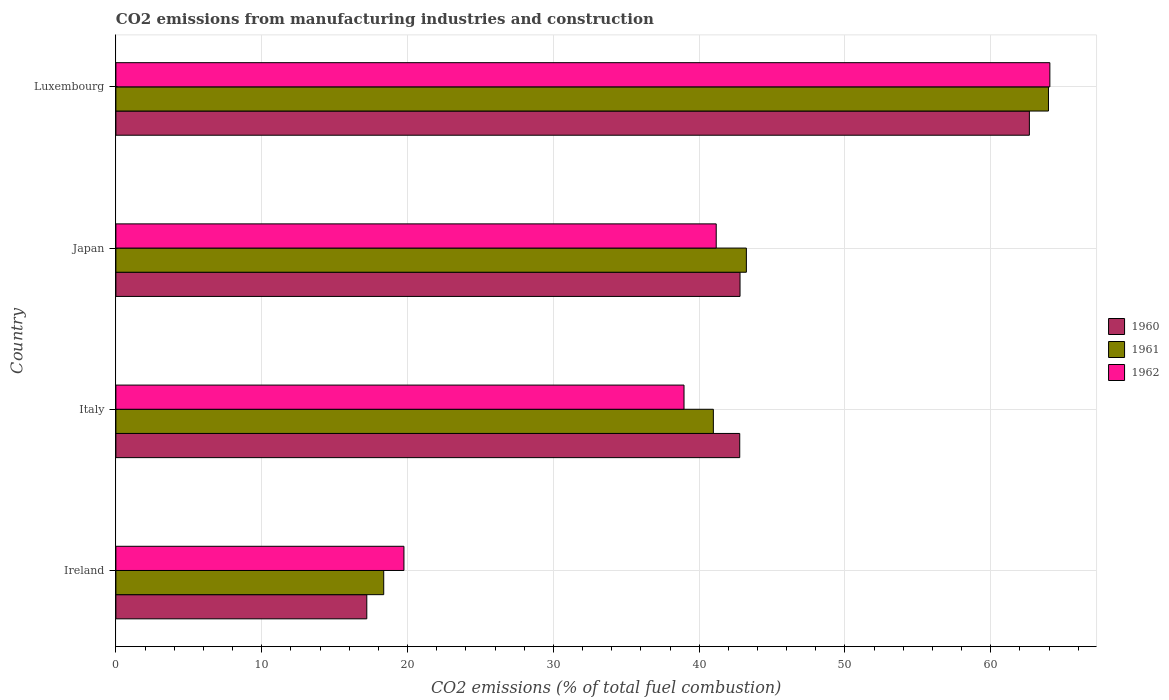How many different coloured bars are there?
Make the answer very short. 3. Are the number of bars on each tick of the Y-axis equal?
Offer a very short reply. Yes. How many bars are there on the 1st tick from the top?
Keep it short and to the point. 3. How many bars are there on the 3rd tick from the bottom?
Your answer should be compact. 3. What is the label of the 4th group of bars from the top?
Offer a terse response. Ireland. In how many cases, is the number of bars for a given country not equal to the number of legend labels?
Offer a terse response. 0. What is the amount of CO2 emitted in 1961 in Luxembourg?
Your answer should be very brief. 63.95. Across all countries, what is the maximum amount of CO2 emitted in 1962?
Give a very brief answer. 64.05. Across all countries, what is the minimum amount of CO2 emitted in 1960?
Ensure brevity in your answer.  17.21. In which country was the amount of CO2 emitted in 1962 maximum?
Offer a terse response. Luxembourg. In which country was the amount of CO2 emitted in 1961 minimum?
Provide a succinct answer. Ireland. What is the total amount of CO2 emitted in 1962 in the graph?
Provide a short and direct response. 163.93. What is the difference between the amount of CO2 emitted in 1961 in Italy and that in Japan?
Your answer should be very brief. -2.26. What is the difference between the amount of CO2 emitted in 1961 in Luxembourg and the amount of CO2 emitted in 1960 in Ireland?
Offer a terse response. 46.75. What is the average amount of CO2 emitted in 1961 per country?
Your response must be concise. 41.63. What is the difference between the amount of CO2 emitted in 1961 and amount of CO2 emitted in 1960 in Ireland?
Make the answer very short. 1.16. In how many countries, is the amount of CO2 emitted in 1962 greater than 18 %?
Your answer should be very brief. 4. What is the ratio of the amount of CO2 emitted in 1962 in Italy to that in Luxembourg?
Ensure brevity in your answer.  0.61. Is the amount of CO2 emitted in 1961 in Ireland less than that in Italy?
Provide a short and direct response. Yes. Is the difference between the amount of CO2 emitted in 1961 in Ireland and Italy greater than the difference between the amount of CO2 emitted in 1960 in Ireland and Italy?
Make the answer very short. Yes. What is the difference between the highest and the second highest amount of CO2 emitted in 1962?
Keep it short and to the point. 22.88. What is the difference between the highest and the lowest amount of CO2 emitted in 1960?
Provide a short and direct response. 45.44. Is the sum of the amount of CO2 emitted in 1962 in Ireland and Japan greater than the maximum amount of CO2 emitted in 1961 across all countries?
Your answer should be compact. No. What does the 2nd bar from the top in Luxembourg represents?
Give a very brief answer. 1961. How many bars are there?
Make the answer very short. 12. Does the graph contain any zero values?
Provide a succinct answer. No. Does the graph contain grids?
Make the answer very short. Yes. Where does the legend appear in the graph?
Provide a short and direct response. Center right. How are the legend labels stacked?
Keep it short and to the point. Vertical. What is the title of the graph?
Your answer should be very brief. CO2 emissions from manufacturing industries and construction. What is the label or title of the X-axis?
Give a very brief answer. CO2 emissions (% of total fuel combustion). What is the CO2 emissions (% of total fuel combustion) in 1960 in Ireland?
Ensure brevity in your answer.  17.21. What is the CO2 emissions (% of total fuel combustion) of 1961 in Ireland?
Your answer should be compact. 18.37. What is the CO2 emissions (% of total fuel combustion) in 1962 in Ireland?
Your answer should be compact. 19.75. What is the CO2 emissions (% of total fuel combustion) of 1960 in Italy?
Keep it short and to the point. 42.78. What is the CO2 emissions (% of total fuel combustion) of 1961 in Italy?
Offer a very short reply. 40.97. What is the CO2 emissions (% of total fuel combustion) in 1962 in Italy?
Ensure brevity in your answer.  38.96. What is the CO2 emissions (% of total fuel combustion) of 1960 in Japan?
Your answer should be very brief. 42.8. What is the CO2 emissions (% of total fuel combustion) of 1961 in Japan?
Your answer should be very brief. 43.24. What is the CO2 emissions (% of total fuel combustion) in 1962 in Japan?
Offer a very short reply. 41.17. What is the CO2 emissions (% of total fuel combustion) in 1960 in Luxembourg?
Your answer should be very brief. 62.65. What is the CO2 emissions (% of total fuel combustion) in 1961 in Luxembourg?
Provide a succinct answer. 63.95. What is the CO2 emissions (% of total fuel combustion) of 1962 in Luxembourg?
Give a very brief answer. 64.05. Across all countries, what is the maximum CO2 emissions (% of total fuel combustion) of 1960?
Make the answer very short. 62.65. Across all countries, what is the maximum CO2 emissions (% of total fuel combustion) in 1961?
Offer a terse response. 63.95. Across all countries, what is the maximum CO2 emissions (% of total fuel combustion) of 1962?
Ensure brevity in your answer.  64.05. Across all countries, what is the minimum CO2 emissions (% of total fuel combustion) in 1960?
Provide a succinct answer. 17.21. Across all countries, what is the minimum CO2 emissions (% of total fuel combustion) of 1961?
Make the answer very short. 18.37. Across all countries, what is the minimum CO2 emissions (% of total fuel combustion) of 1962?
Provide a short and direct response. 19.75. What is the total CO2 emissions (% of total fuel combustion) in 1960 in the graph?
Give a very brief answer. 165.44. What is the total CO2 emissions (% of total fuel combustion) of 1961 in the graph?
Your answer should be compact. 166.53. What is the total CO2 emissions (% of total fuel combustion) of 1962 in the graph?
Offer a very short reply. 163.93. What is the difference between the CO2 emissions (% of total fuel combustion) in 1960 in Ireland and that in Italy?
Your answer should be very brief. -25.57. What is the difference between the CO2 emissions (% of total fuel combustion) in 1961 in Ireland and that in Italy?
Your answer should be compact. -22.61. What is the difference between the CO2 emissions (% of total fuel combustion) of 1962 in Ireland and that in Italy?
Keep it short and to the point. -19.21. What is the difference between the CO2 emissions (% of total fuel combustion) in 1960 in Ireland and that in Japan?
Your answer should be very brief. -25.6. What is the difference between the CO2 emissions (% of total fuel combustion) of 1961 in Ireland and that in Japan?
Make the answer very short. -24.87. What is the difference between the CO2 emissions (% of total fuel combustion) of 1962 in Ireland and that in Japan?
Offer a terse response. -21.42. What is the difference between the CO2 emissions (% of total fuel combustion) in 1960 in Ireland and that in Luxembourg?
Make the answer very short. -45.44. What is the difference between the CO2 emissions (% of total fuel combustion) of 1961 in Ireland and that in Luxembourg?
Your response must be concise. -45.59. What is the difference between the CO2 emissions (% of total fuel combustion) of 1962 in Ireland and that in Luxembourg?
Your response must be concise. -44.3. What is the difference between the CO2 emissions (% of total fuel combustion) of 1960 in Italy and that in Japan?
Your answer should be very brief. -0.02. What is the difference between the CO2 emissions (% of total fuel combustion) in 1961 in Italy and that in Japan?
Offer a very short reply. -2.26. What is the difference between the CO2 emissions (% of total fuel combustion) in 1962 in Italy and that in Japan?
Your answer should be compact. -2.21. What is the difference between the CO2 emissions (% of total fuel combustion) in 1960 in Italy and that in Luxembourg?
Provide a short and direct response. -19.86. What is the difference between the CO2 emissions (% of total fuel combustion) of 1961 in Italy and that in Luxembourg?
Offer a terse response. -22.98. What is the difference between the CO2 emissions (% of total fuel combustion) of 1962 in Italy and that in Luxembourg?
Make the answer very short. -25.09. What is the difference between the CO2 emissions (% of total fuel combustion) of 1960 in Japan and that in Luxembourg?
Provide a short and direct response. -19.84. What is the difference between the CO2 emissions (% of total fuel combustion) in 1961 in Japan and that in Luxembourg?
Offer a very short reply. -20.72. What is the difference between the CO2 emissions (% of total fuel combustion) in 1962 in Japan and that in Luxembourg?
Your answer should be compact. -22.88. What is the difference between the CO2 emissions (% of total fuel combustion) of 1960 in Ireland and the CO2 emissions (% of total fuel combustion) of 1961 in Italy?
Your response must be concise. -23.77. What is the difference between the CO2 emissions (% of total fuel combustion) in 1960 in Ireland and the CO2 emissions (% of total fuel combustion) in 1962 in Italy?
Your response must be concise. -21.75. What is the difference between the CO2 emissions (% of total fuel combustion) of 1961 in Ireland and the CO2 emissions (% of total fuel combustion) of 1962 in Italy?
Your answer should be compact. -20.59. What is the difference between the CO2 emissions (% of total fuel combustion) in 1960 in Ireland and the CO2 emissions (% of total fuel combustion) in 1961 in Japan?
Provide a succinct answer. -26.03. What is the difference between the CO2 emissions (% of total fuel combustion) in 1960 in Ireland and the CO2 emissions (% of total fuel combustion) in 1962 in Japan?
Provide a short and direct response. -23.96. What is the difference between the CO2 emissions (% of total fuel combustion) of 1961 in Ireland and the CO2 emissions (% of total fuel combustion) of 1962 in Japan?
Your response must be concise. -22.8. What is the difference between the CO2 emissions (% of total fuel combustion) of 1960 in Ireland and the CO2 emissions (% of total fuel combustion) of 1961 in Luxembourg?
Provide a short and direct response. -46.75. What is the difference between the CO2 emissions (% of total fuel combustion) of 1960 in Ireland and the CO2 emissions (% of total fuel combustion) of 1962 in Luxembourg?
Offer a very short reply. -46.84. What is the difference between the CO2 emissions (% of total fuel combustion) of 1961 in Ireland and the CO2 emissions (% of total fuel combustion) of 1962 in Luxembourg?
Ensure brevity in your answer.  -45.68. What is the difference between the CO2 emissions (% of total fuel combustion) of 1960 in Italy and the CO2 emissions (% of total fuel combustion) of 1961 in Japan?
Ensure brevity in your answer.  -0.46. What is the difference between the CO2 emissions (% of total fuel combustion) of 1960 in Italy and the CO2 emissions (% of total fuel combustion) of 1962 in Japan?
Offer a very short reply. 1.61. What is the difference between the CO2 emissions (% of total fuel combustion) of 1961 in Italy and the CO2 emissions (% of total fuel combustion) of 1962 in Japan?
Offer a very short reply. -0.2. What is the difference between the CO2 emissions (% of total fuel combustion) in 1960 in Italy and the CO2 emissions (% of total fuel combustion) in 1961 in Luxembourg?
Keep it short and to the point. -21.17. What is the difference between the CO2 emissions (% of total fuel combustion) in 1960 in Italy and the CO2 emissions (% of total fuel combustion) in 1962 in Luxembourg?
Your answer should be very brief. -21.27. What is the difference between the CO2 emissions (% of total fuel combustion) in 1961 in Italy and the CO2 emissions (% of total fuel combustion) in 1962 in Luxembourg?
Your answer should be very brief. -23.08. What is the difference between the CO2 emissions (% of total fuel combustion) in 1960 in Japan and the CO2 emissions (% of total fuel combustion) in 1961 in Luxembourg?
Ensure brevity in your answer.  -21.15. What is the difference between the CO2 emissions (% of total fuel combustion) of 1960 in Japan and the CO2 emissions (% of total fuel combustion) of 1962 in Luxembourg?
Keep it short and to the point. -21.25. What is the difference between the CO2 emissions (% of total fuel combustion) in 1961 in Japan and the CO2 emissions (% of total fuel combustion) in 1962 in Luxembourg?
Your response must be concise. -20.81. What is the average CO2 emissions (% of total fuel combustion) in 1960 per country?
Keep it short and to the point. 41.36. What is the average CO2 emissions (% of total fuel combustion) of 1961 per country?
Give a very brief answer. 41.63. What is the average CO2 emissions (% of total fuel combustion) in 1962 per country?
Your response must be concise. 40.98. What is the difference between the CO2 emissions (% of total fuel combustion) of 1960 and CO2 emissions (% of total fuel combustion) of 1961 in Ireland?
Give a very brief answer. -1.16. What is the difference between the CO2 emissions (% of total fuel combustion) of 1960 and CO2 emissions (% of total fuel combustion) of 1962 in Ireland?
Offer a very short reply. -2.55. What is the difference between the CO2 emissions (% of total fuel combustion) in 1961 and CO2 emissions (% of total fuel combustion) in 1962 in Ireland?
Your response must be concise. -1.39. What is the difference between the CO2 emissions (% of total fuel combustion) in 1960 and CO2 emissions (% of total fuel combustion) in 1961 in Italy?
Make the answer very short. 1.81. What is the difference between the CO2 emissions (% of total fuel combustion) in 1960 and CO2 emissions (% of total fuel combustion) in 1962 in Italy?
Keep it short and to the point. 3.82. What is the difference between the CO2 emissions (% of total fuel combustion) of 1961 and CO2 emissions (% of total fuel combustion) of 1962 in Italy?
Offer a terse response. 2.01. What is the difference between the CO2 emissions (% of total fuel combustion) in 1960 and CO2 emissions (% of total fuel combustion) in 1961 in Japan?
Offer a very short reply. -0.44. What is the difference between the CO2 emissions (% of total fuel combustion) in 1960 and CO2 emissions (% of total fuel combustion) in 1962 in Japan?
Provide a succinct answer. 1.63. What is the difference between the CO2 emissions (% of total fuel combustion) in 1961 and CO2 emissions (% of total fuel combustion) in 1962 in Japan?
Offer a terse response. 2.07. What is the difference between the CO2 emissions (% of total fuel combustion) in 1960 and CO2 emissions (% of total fuel combustion) in 1961 in Luxembourg?
Offer a terse response. -1.31. What is the difference between the CO2 emissions (% of total fuel combustion) of 1960 and CO2 emissions (% of total fuel combustion) of 1962 in Luxembourg?
Your response must be concise. -1.4. What is the difference between the CO2 emissions (% of total fuel combustion) in 1961 and CO2 emissions (% of total fuel combustion) in 1962 in Luxembourg?
Provide a succinct answer. -0.1. What is the ratio of the CO2 emissions (% of total fuel combustion) in 1960 in Ireland to that in Italy?
Your response must be concise. 0.4. What is the ratio of the CO2 emissions (% of total fuel combustion) of 1961 in Ireland to that in Italy?
Your answer should be very brief. 0.45. What is the ratio of the CO2 emissions (% of total fuel combustion) of 1962 in Ireland to that in Italy?
Your response must be concise. 0.51. What is the ratio of the CO2 emissions (% of total fuel combustion) in 1960 in Ireland to that in Japan?
Provide a succinct answer. 0.4. What is the ratio of the CO2 emissions (% of total fuel combustion) in 1961 in Ireland to that in Japan?
Offer a terse response. 0.42. What is the ratio of the CO2 emissions (% of total fuel combustion) in 1962 in Ireland to that in Japan?
Offer a terse response. 0.48. What is the ratio of the CO2 emissions (% of total fuel combustion) in 1960 in Ireland to that in Luxembourg?
Give a very brief answer. 0.27. What is the ratio of the CO2 emissions (% of total fuel combustion) of 1961 in Ireland to that in Luxembourg?
Make the answer very short. 0.29. What is the ratio of the CO2 emissions (% of total fuel combustion) in 1962 in Ireland to that in Luxembourg?
Offer a terse response. 0.31. What is the ratio of the CO2 emissions (% of total fuel combustion) in 1961 in Italy to that in Japan?
Provide a short and direct response. 0.95. What is the ratio of the CO2 emissions (% of total fuel combustion) in 1962 in Italy to that in Japan?
Offer a very short reply. 0.95. What is the ratio of the CO2 emissions (% of total fuel combustion) of 1960 in Italy to that in Luxembourg?
Ensure brevity in your answer.  0.68. What is the ratio of the CO2 emissions (% of total fuel combustion) in 1961 in Italy to that in Luxembourg?
Offer a very short reply. 0.64. What is the ratio of the CO2 emissions (% of total fuel combustion) of 1962 in Italy to that in Luxembourg?
Offer a terse response. 0.61. What is the ratio of the CO2 emissions (% of total fuel combustion) of 1960 in Japan to that in Luxembourg?
Your response must be concise. 0.68. What is the ratio of the CO2 emissions (% of total fuel combustion) of 1961 in Japan to that in Luxembourg?
Your response must be concise. 0.68. What is the ratio of the CO2 emissions (% of total fuel combustion) in 1962 in Japan to that in Luxembourg?
Keep it short and to the point. 0.64. What is the difference between the highest and the second highest CO2 emissions (% of total fuel combustion) in 1960?
Keep it short and to the point. 19.84. What is the difference between the highest and the second highest CO2 emissions (% of total fuel combustion) in 1961?
Your response must be concise. 20.72. What is the difference between the highest and the second highest CO2 emissions (% of total fuel combustion) in 1962?
Your answer should be very brief. 22.88. What is the difference between the highest and the lowest CO2 emissions (% of total fuel combustion) in 1960?
Keep it short and to the point. 45.44. What is the difference between the highest and the lowest CO2 emissions (% of total fuel combustion) of 1961?
Your response must be concise. 45.59. What is the difference between the highest and the lowest CO2 emissions (% of total fuel combustion) in 1962?
Offer a terse response. 44.3. 